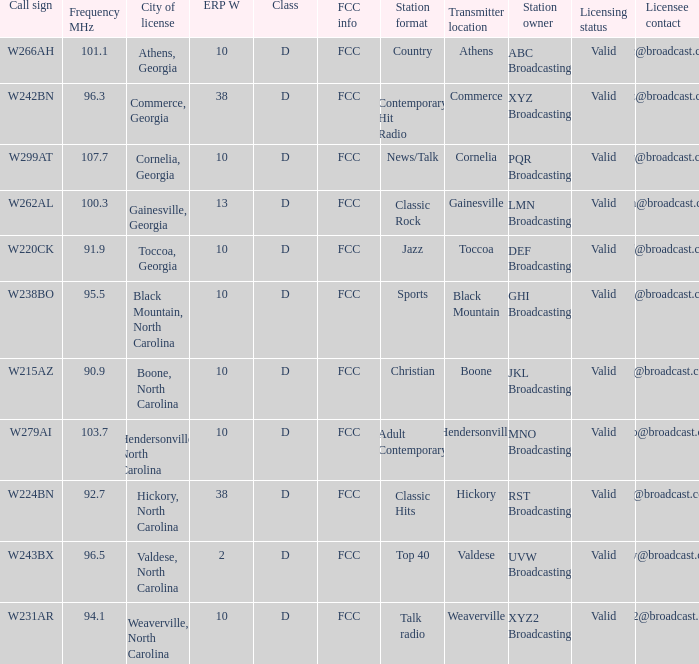What city has larger than 94.1 as a frequency? Athens, Georgia, Commerce, Georgia, Cornelia, Georgia, Gainesville, Georgia, Black Mountain, North Carolina, Hendersonville, North Carolina, Valdese, North Carolina. 